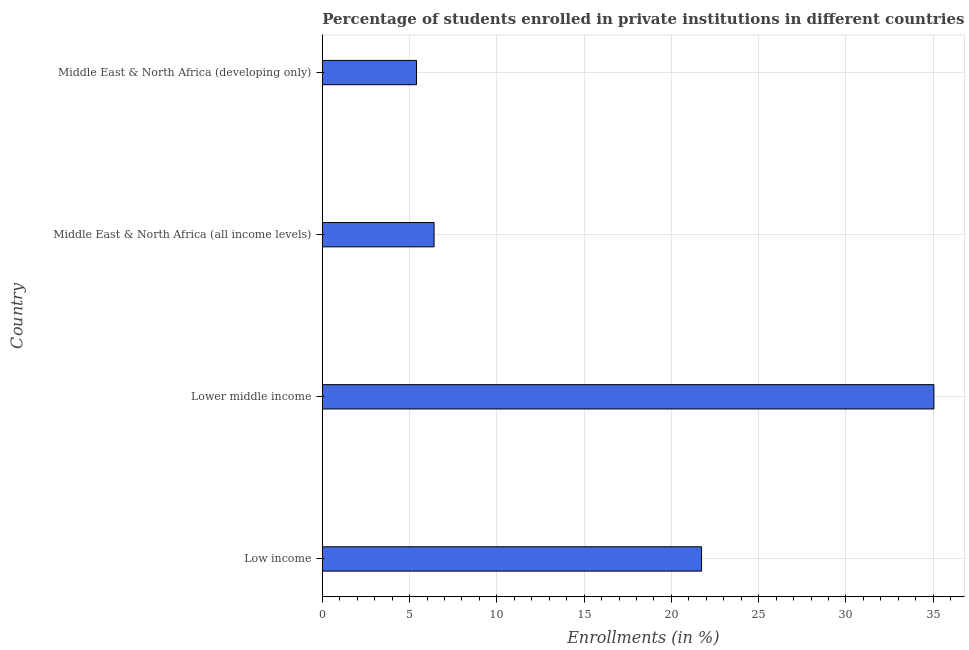Does the graph contain grids?
Give a very brief answer. Yes. What is the title of the graph?
Your answer should be very brief. Percentage of students enrolled in private institutions in different countries. What is the label or title of the X-axis?
Provide a short and direct response. Enrollments (in %). What is the enrollments in private institutions in Low income?
Provide a short and direct response. 21.73. Across all countries, what is the maximum enrollments in private institutions?
Keep it short and to the point. 35.04. Across all countries, what is the minimum enrollments in private institutions?
Provide a succinct answer. 5.39. In which country was the enrollments in private institutions maximum?
Your response must be concise. Lower middle income. In which country was the enrollments in private institutions minimum?
Ensure brevity in your answer.  Middle East & North Africa (developing only). What is the sum of the enrollments in private institutions?
Give a very brief answer. 68.56. What is the difference between the enrollments in private institutions in Low income and Lower middle income?
Your answer should be compact. -13.31. What is the average enrollments in private institutions per country?
Provide a succinct answer. 17.14. What is the median enrollments in private institutions?
Offer a terse response. 14.06. What is the ratio of the enrollments in private institutions in Low income to that in Lower middle income?
Offer a terse response. 0.62. Is the enrollments in private institutions in Lower middle income less than that in Middle East & North Africa (all income levels)?
Provide a succinct answer. No. Is the difference between the enrollments in private institutions in Low income and Middle East & North Africa (all income levels) greater than the difference between any two countries?
Your answer should be compact. No. What is the difference between the highest and the second highest enrollments in private institutions?
Ensure brevity in your answer.  13.31. Is the sum of the enrollments in private institutions in Lower middle income and Middle East & North Africa (all income levels) greater than the maximum enrollments in private institutions across all countries?
Make the answer very short. Yes. What is the difference between the highest and the lowest enrollments in private institutions?
Offer a terse response. 29.65. How many bars are there?
Your answer should be compact. 4. How many countries are there in the graph?
Make the answer very short. 4. What is the difference between two consecutive major ticks on the X-axis?
Your response must be concise. 5. What is the Enrollments (in %) of Low income?
Keep it short and to the point. 21.73. What is the Enrollments (in %) in Lower middle income?
Ensure brevity in your answer.  35.04. What is the Enrollments (in %) in Middle East & North Africa (all income levels)?
Offer a very short reply. 6.4. What is the Enrollments (in %) in Middle East & North Africa (developing only)?
Your answer should be compact. 5.39. What is the difference between the Enrollments (in %) in Low income and Lower middle income?
Your answer should be compact. -13.31. What is the difference between the Enrollments (in %) in Low income and Middle East & North Africa (all income levels)?
Your answer should be very brief. 15.33. What is the difference between the Enrollments (in %) in Low income and Middle East & North Africa (developing only)?
Provide a short and direct response. 16.33. What is the difference between the Enrollments (in %) in Lower middle income and Middle East & North Africa (all income levels)?
Offer a terse response. 28.64. What is the difference between the Enrollments (in %) in Lower middle income and Middle East & North Africa (developing only)?
Ensure brevity in your answer.  29.65. What is the difference between the Enrollments (in %) in Middle East & North Africa (all income levels) and Middle East & North Africa (developing only)?
Make the answer very short. 1.01. What is the ratio of the Enrollments (in %) in Low income to that in Lower middle income?
Give a very brief answer. 0.62. What is the ratio of the Enrollments (in %) in Low income to that in Middle East & North Africa (all income levels)?
Offer a terse response. 3.39. What is the ratio of the Enrollments (in %) in Low income to that in Middle East & North Africa (developing only)?
Offer a terse response. 4.03. What is the ratio of the Enrollments (in %) in Lower middle income to that in Middle East & North Africa (all income levels)?
Your answer should be very brief. 5.47. What is the ratio of the Enrollments (in %) in Lower middle income to that in Middle East & North Africa (developing only)?
Your answer should be very brief. 6.5. What is the ratio of the Enrollments (in %) in Middle East & North Africa (all income levels) to that in Middle East & North Africa (developing only)?
Your response must be concise. 1.19. 